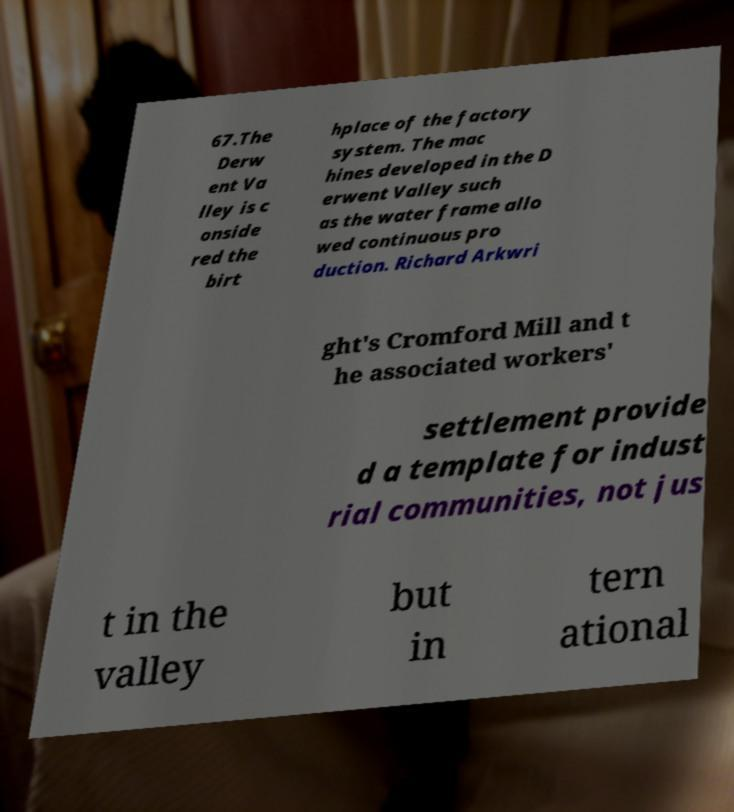I need the written content from this picture converted into text. Can you do that? 67.The Derw ent Va lley is c onside red the birt hplace of the factory system. The mac hines developed in the D erwent Valley such as the water frame allo wed continuous pro duction. Richard Arkwri ght's Cromford Mill and t he associated workers' settlement provide d a template for indust rial communities, not jus t in the valley but in tern ational 